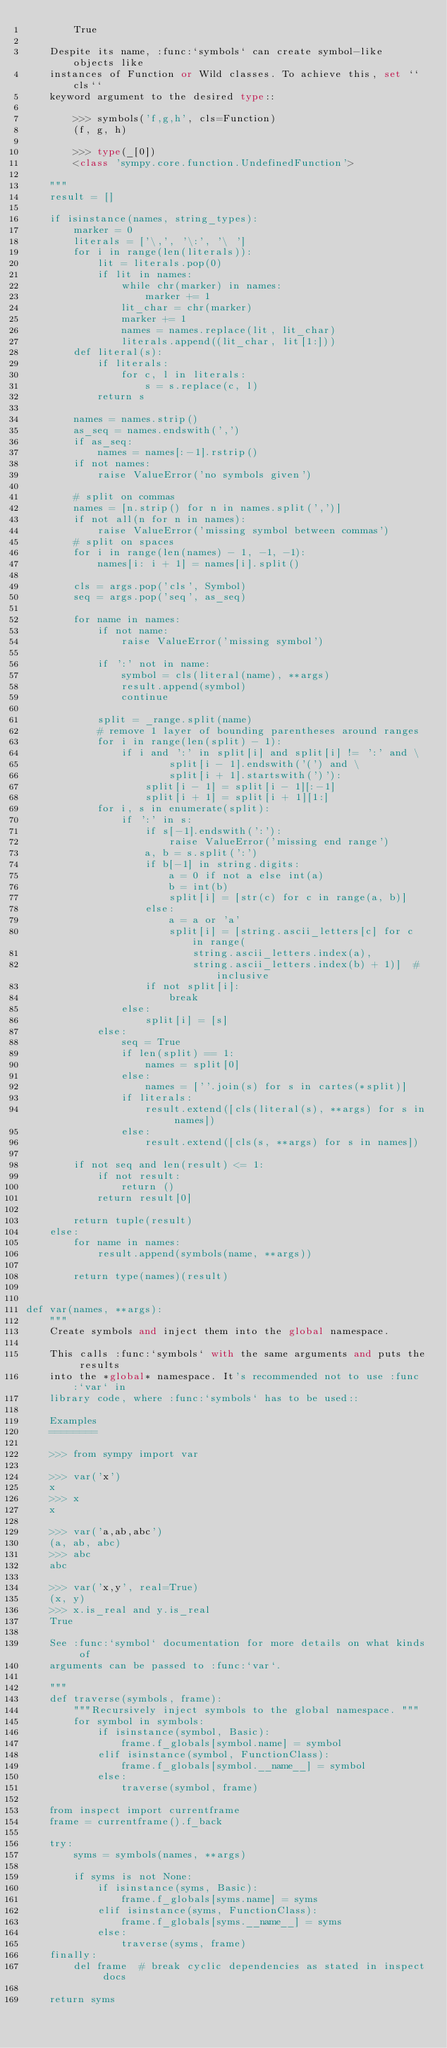Convert code to text. <code><loc_0><loc_0><loc_500><loc_500><_Python_>        True

    Despite its name, :func:`symbols` can create symbol-like objects like
    instances of Function or Wild classes. To achieve this, set ``cls``
    keyword argument to the desired type::

        >>> symbols('f,g,h', cls=Function)
        (f, g, h)

        >>> type(_[0])
        <class 'sympy.core.function.UndefinedFunction'>

    """
    result = []

    if isinstance(names, string_types):
        marker = 0
        literals = ['\,', '\:', '\ ']
        for i in range(len(literals)):
            lit = literals.pop(0)
            if lit in names:
                while chr(marker) in names:
                    marker += 1
                lit_char = chr(marker)
                marker += 1
                names = names.replace(lit, lit_char)
                literals.append((lit_char, lit[1:]))
        def literal(s):
            if literals:
                for c, l in literals:
                    s = s.replace(c, l)
            return s

        names = names.strip()
        as_seq = names.endswith(',')
        if as_seq:
            names = names[:-1].rstrip()
        if not names:
            raise ValueError('no symbols given')

        # split on commas
        names = [n.strip() for n in names.split(',')]
        if not all(n for n in names):
            raise ValueError('missing symbol between commas')
        # split on spaces
        for i in range(len(names) - 1, -1, -1):
            names[i: i + 1] = names[i].split()

        cls = args.pop('cls', Symbol)
        seq = args.pop('seq', as_seq)

        for name in names:
            if not name:
                raise ValueError('missing symbol')

            if ':' not in name:
                symbol = cls(literal(name), **args)
                result.append(symbol)
                continue

            split = _range.split(name)
            # remove 1 layer of bounding parentheses around ranges
            for i in range(len(split) - 1):
                if i and ':' in split[i] and split[i] != ':' and \
                        split[i - 1].endswith('(') and \
                        split[i + 1].startswith(')'):
                    split[i - 1] = split[i - 1][:-1]
                    split[i + 1] = split[i + 1][1:]
            for i, s in enumerate(split):
                if ':' in s:
                    if s[-1].endswith(':'):
                        raise ValueError('missing end range')
                    a, b = s.split(':')
                    if b[-1] in string.digits:
                        a = 0 if not a else int(a)
                        b = int(b)
                        split[i] = [str(c) for c in range(a, b)]
                    else:
                        a = a or 'a'
                        split[i] = [string.ascii_letters[c] for c in range(
                            string.ascii_letters.index(a),
                            string.ascii_letters.index(b) + 1)]  # inclusive
                    if not split[i]:
                        break
                else:
                    split[i] = [s]
            else:
                seq = True
                if len(split) == 1:
                    names = split[0]
                else:
                    names = [''.join(s) for s in cartes(*split)]
                if literals:
                    result.extend([cls(literal(s), **args) for s in names])
                else:
                    result.extend([cls(s, **args) for s in names])

        if not seq and len(result) <= 1:
            if not result:
                return ()
            return result[0]

        return tuple(result)
    else:
        for name in names:
            result.append(symbols(name, **args))

        return type(names)(result)


def var(names, **args):
    """
    Create symbols and inject them into the global namespace.

    This calls :func:`symbols` with the same arguments and puts the results
    into the *global* namespace. It's recommended not to use :func:`var` in
    library code, where :func:`symbols` has to be used::

    Examples
    ========

    >>> from sympy import var

    >>> var('x')
    x
    >>> x
    x

    >>> var('a,ab,abc')
    (a, ab, abc)
    >>> abc
    abc

    >>> var('x,y', real=True)
    (x, y)
    >>> x.is_real and y.is_real
    True

    See :func:`symbol` documentation for more details on what kinds of
    arguments can be passed to :func:`var`.

    """
    def traverse(symbols, frame):
        """Recursively inject symbols to the global namespace. """
        for symbol in symbols:
            if isinstance(symbol, Basic):
                frame.f_globals[symbol.name] = symbol
            elif isinstance(symbol, FunctionClass):
                frame.f_globals[symbol.__name__] = symbol
            else:
                traverse(symbol, frame)

    from inspect import currentframe
    frame = currentframe().f_back

    try:
        syms = symbols(names, **args)

        if syms is not None:
            if isinstance(syms, Basic):
                frame.f_globals[syms.name] = syms
            elif isinstance(syms, FunctionClass):
                frame.f_globals[syms.__name__] = syms
            else:
                traverse(syms, frame)
    finally:
        del frame  # break cyclic dependencies as stated in inspect docs

    return syms
</code> 